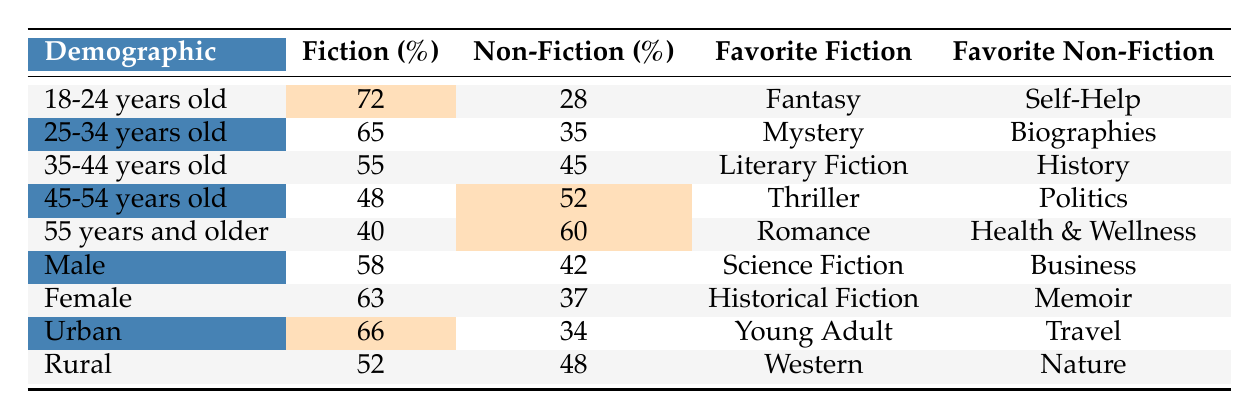What percentage of 18-24-year-olds prefer fiction? According to the table, 72% of 18-24-year-olds prefer fiction.
Answer: 72% What is the favorite non-fiction genre of readers aged 45-54? The favorite non-fiction genre for the 45-54 age group is Politics.
Answer: Politics Which demographic shows the highest percentage of non-fiction preference? The demographic with the highest percentage of non-fiction preference is those aged 55 and older, at 60%.
Answer: 55 and older What is the difference in fiction preference between 35-44 year-olds and 45-54 year-olds? The fiction preference for 35-44 year-olds is 55%, and for 45-54 year-olds, it is 48%. The difference is 55% - 48% = 7%.
Answer: 7% True or false: Female readers prefer Science Fiction over Historical Fiction. According to the table, female readers have a favorite genre of Historical Fiction, which is higher than their percentage for Science Fiction (63% vs 58%). Therefore, this statement is false.
Answer: False What is the average fiction preference percentage of urban and rural readers? The fiction preference percentage for urban readers is 66%, and for rural readers, it is 52%. The average is (66% + 52%) / 2 = 59%.
Answer: 59% Which age group has the least preference for fiction? The age group with the least preference for fiction is those 55 years and older, at 40%.
Answer: 55 years and older What is the percentage of fiction lovers among males compared to females? Male readers have a fiction preference of 58%, whereas females have a preference of 63%. Female readers have a higher percentage than male readers.
Answer: 63% vs 58% What is the total percentage of fiction preference across all the demographic groups? By summing the percentages of fiction preferences: 72 + 65 + 55 + 48 + 40 + 58 + 63 + 66 + 52 = 419%. The total percentage for all is 419%.
Answer: 419% Which non-fiction genre do younger readers prefer the most compared to other demographics? Younger readers (18-24 years old) prefer Self-Help as their favorite non-fiction genre, whereas other demographics have different preferences, like Biographies (25-34), History (35-44), Politics (45-54), and Health & Wellness (55 and older).
Answer: Self-Help 